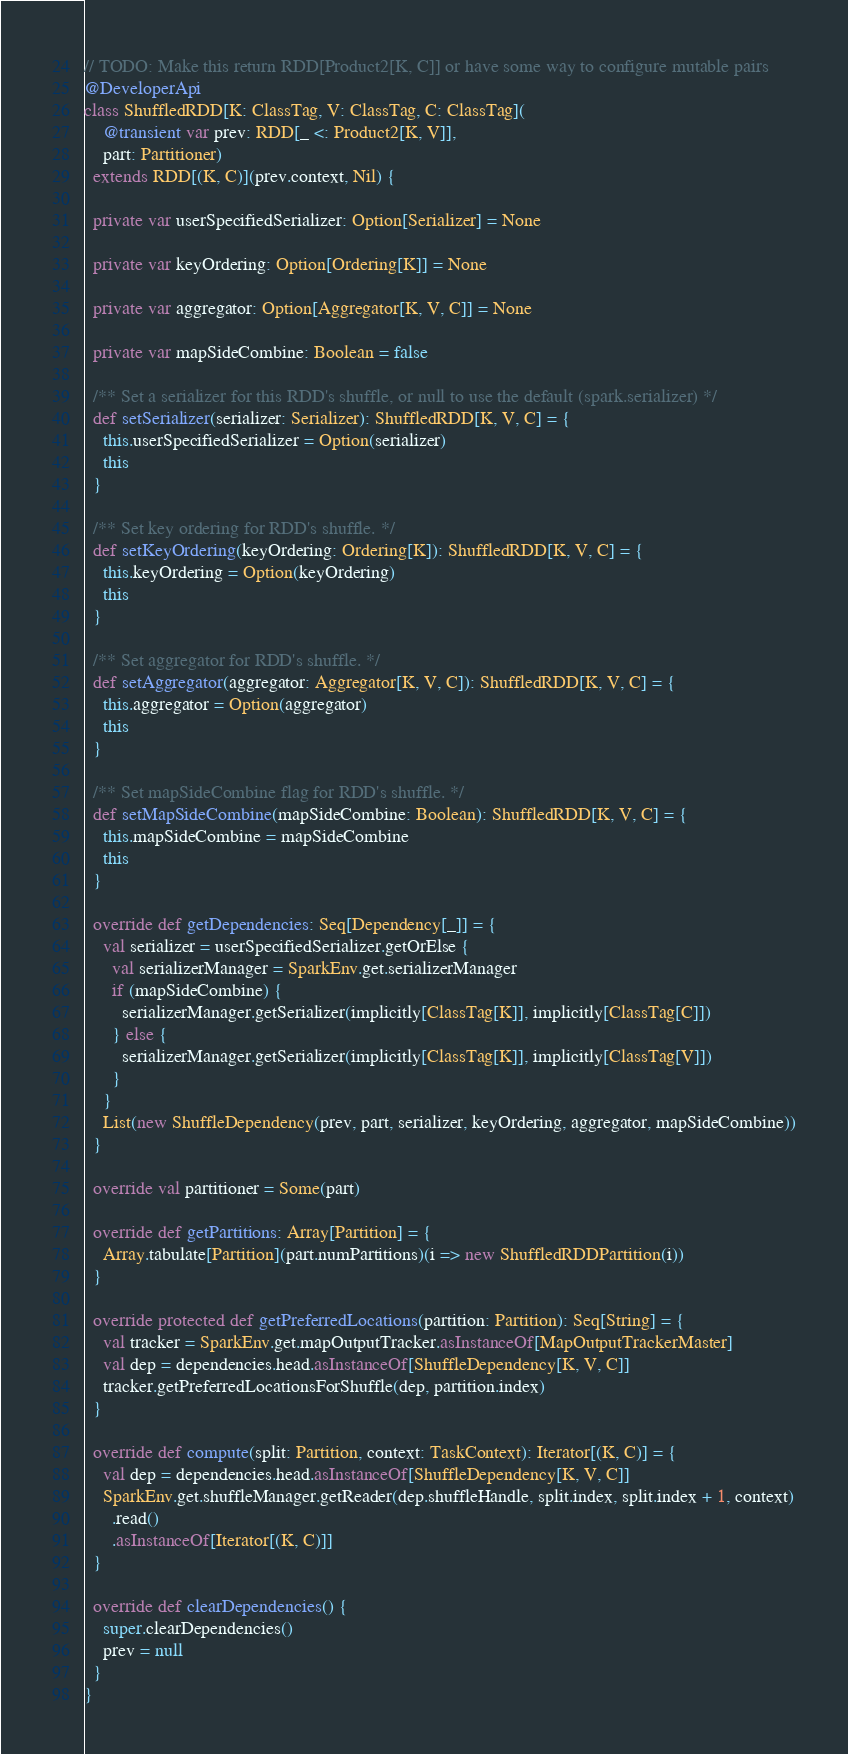<code> <loc_0><loc_0><loc_500><loc_500><_Scala_>// TODO: Make this return RDD[Product2[K, C]] or have some way to configure mutable pairs
@DeveloperApi
class ShuffledRDD[K: ClassTag, V: ClassTag, C: ClassTag](
    @transient var prev: RDD[_ <: Product2[K, V]],
    part: Partitioner)
  extends RDD[(K, C)](prev.context, Nil) {

  private var userSpecifiedSerializer: Option[Serializer] = None

  private var keyOrdering: Option[Ordering[K]] = None

  private var aggregator: Option[Aggregator[K, V, C]] = None

  private var mapSideCombine: Boolean = false

  /** Set a serializer for this RDD's shuffle, or null to use the default (spark.serializer) */
  def setSerializer(serializer: Serializer): ShuffledRDD[K, V, C] = {
    this.userSpecifiedSerializer = Option(serializer)
    this
  }

  /** Set key ordering for RDD's shuffle. */
  def setKeyOrdering(keyOrdering: Ordering[K]): ShuffledRDD[K, V, C] = {
    this.keyOrdering = Option(keyOrdering)
    this
  }

  /** Set aggregator for RDD's shuffle. */
  def setAggregator(aggregator: Aggregator[K, V, C]): ShuffledRDD[K, V, C] = {
    this.aggregator = Option(aggregator)
    this
  }

  /** Set mapSideCombine flag for RDD's shuffle. */
  def setMapSideCombine(mapSideCombine: Boolean): ShuffledRDD[K, V, C] = {
    this.mapSideCombine = mapSideCombine
    this
  }

  override def getDependencies: Seq[Dependency[_]] = {
    val serializer = userSpecifiedSerializer.getOrElse {
      val serializerManager = SparkEnv.get.serializerManager
      if (mapSideCombine) {
        serializerManager.getSerializer(implicitly[ClassTag[K]], implicitly[ClassTag[C]])
      } else {
        serializerManager.getSerializer(implicitly[ClassTag[K]], implicitly[ClassTag[V]])
      }
    }
    List(new ShuffleDependency(prev, part, serializer, keyOrdering, aggregator, mapSideCombine))
  }

  override val partitioner = Some(part)

  override def getPartitions: Array[Partition] = {
    Array.tabulate[Partition](part.numPartitions)(i => new ShuffledRDDPartition(i))
  }

  override protected def getPreferredLocations(partition: Partition): Seq[String] = {
    val tracker = SparkEnv.get.mapOutputTracker.asInstanceOf[MapOutputTrackerMaster]
    val dep = dependencies.head.asInstanceOf[ShuffleDependency[K, V, C]]
    tracker.getPreferredLocationsForShuffle(dep, partition.index)
  }

  override def compute(split: Partition, context: TaskContext): Iterator[(K, C)] = {
    val dep = dependencies.head.asInstanceOf[ShuffleDependency[K, V, C]]
    SparkEnv.get.shuffleManager.getReader(dep.shuffleHandle, split.index, split.index + 1, context)
      .read()
      .asInstanceOf[Iterator[(K, C)]]
  }

  override def clearDependencies() {
    super.clearDependencies()
    prev = null
  }
}
</code> 